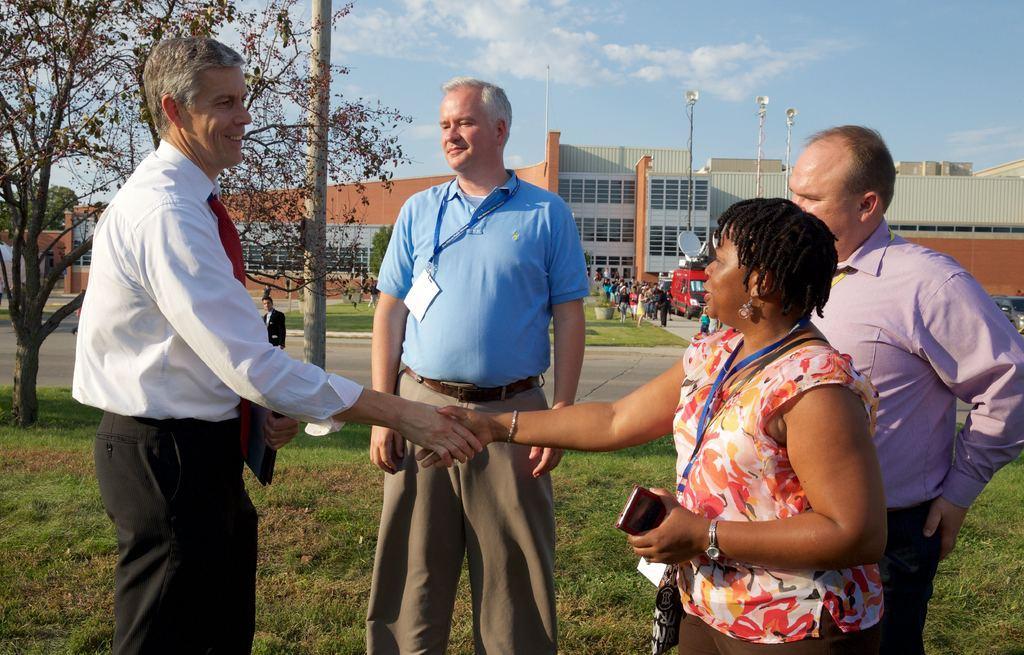Please provide a concise description of this image. In This image there are three men and a woman standing on a ground man and woman are shaking hands, in the background there is a road on that road there are people standing and there is a building on the left side there is a tree. 